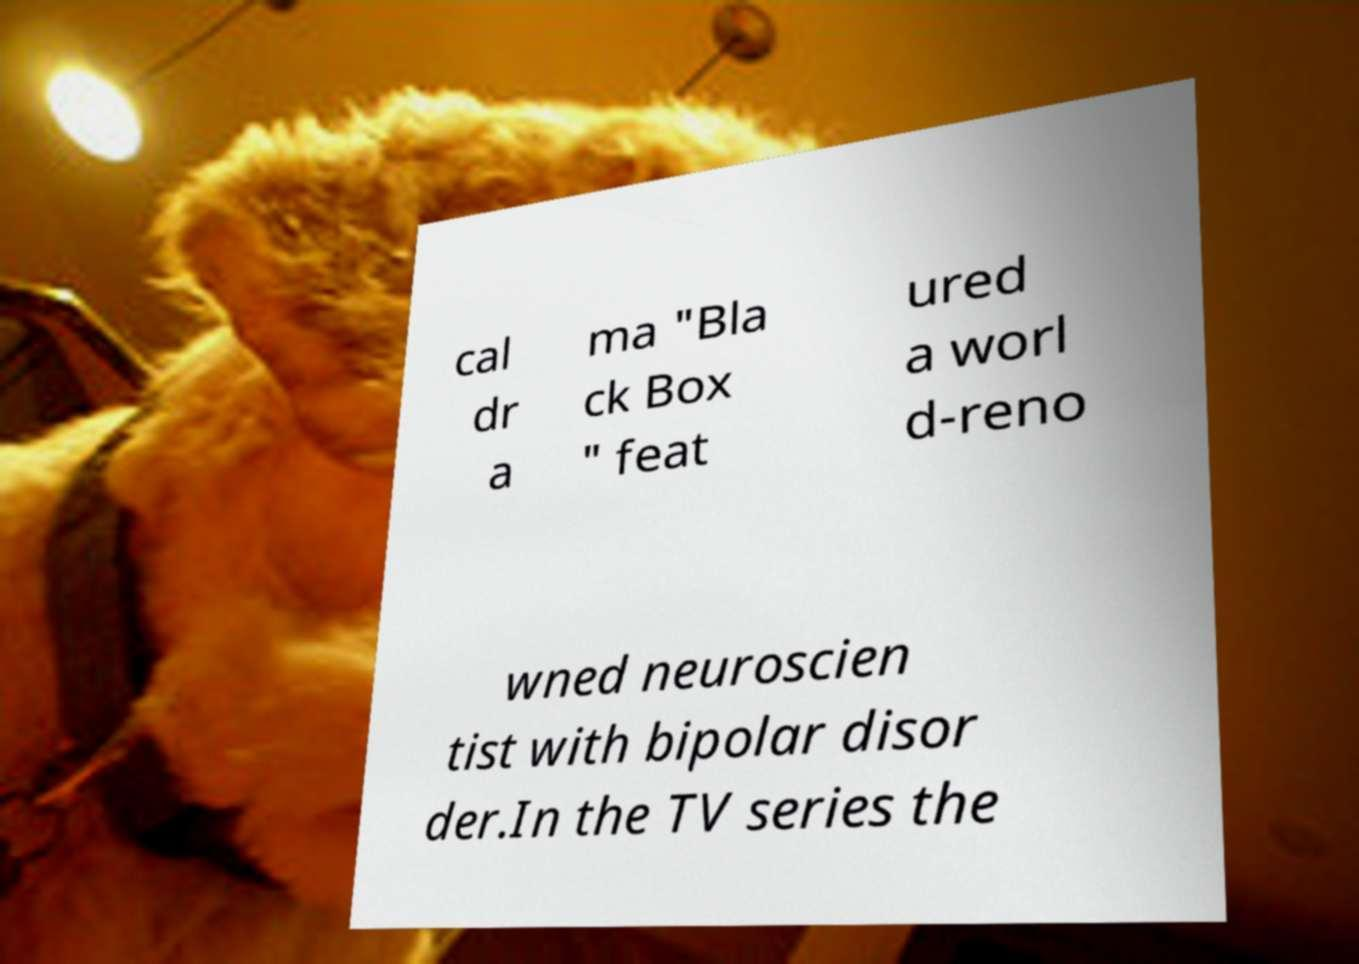There's text embedded in this image that I need extracted. Can you transcribe it verbatim? cal dr a ma "Bla ck Box " feat ured a worl d-reno wned neuroscien tist with bipolar disor der.In the TV series the 